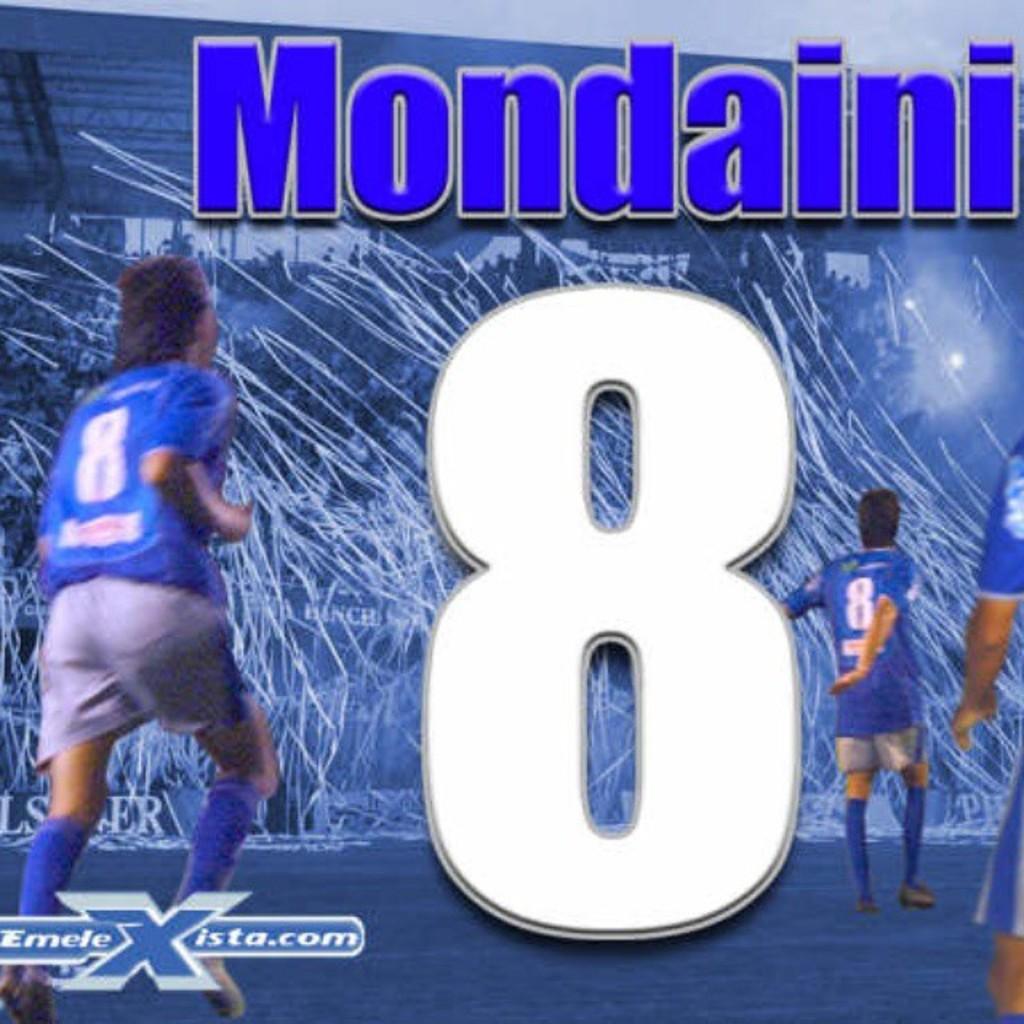What number is large and white in this image?
Keep it short and to the point. 8. Who wears number 8?
Provide a short and direct response. Mondaini. 